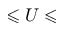Convert formula to latex. <formula><loc_0><loc_0><loc_500><loc_500>\leqslant U \leqslant</formula> 